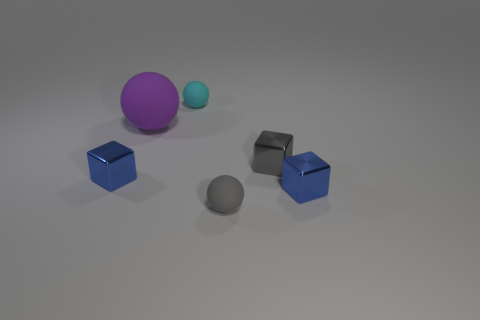Are there any other things that are the same size as the purple sphere?
Give a very brief answer. No. What number of objects are either tiny blue cubes that are left of the tiny cyan rubber thing or blue metal objects?
Ensure brevity in your answer.  2. What is the color of the sphere in front of the blue cube that is to the left of the small rubber sphere that is left of the tiny gray rubber ball?
Keep it short and to the point. Gray. The other small ball that is made of the same material as the cyan sphere is what color?
Offer a very short reply. Gray. How many gray balls have the same material as the big purple ball?
Give a very brief answer. 1. There is a matte object behind the purple ball; is its size the same as the big purple object?
Offer a terse response. No. What is the color of the other rubber ball that is the same size as the gray sphere?
Your answer should be very brief. Cyan. There is a big matte sphere; how many blue metal blocks are behind it?
Provide a short and direct response. 0. Are there any purple matte cylinders?
Provide a short and direct response. No. What is the size of the blue metal thing on the left side of the big purple matte ball behind the ball that is right of the tiny cyan object?
Your response must be concise. Small. 